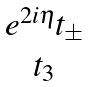<formula> <loc_0><loc_0><loc_500><loc_500>\begin{matrix} e ^ { 2 i \eta } t _ { \pm } \\ t _ { 3 } \end{matrix}</formula> 